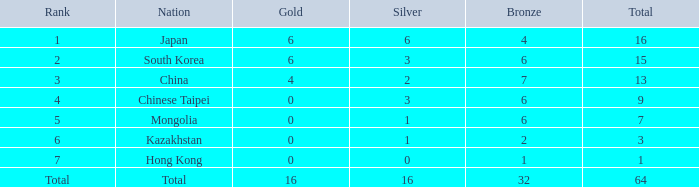Which Silver is the lowest one that has a Gold larger than 0, and a Rank of total, and a Bronze smaller than 32? None. 